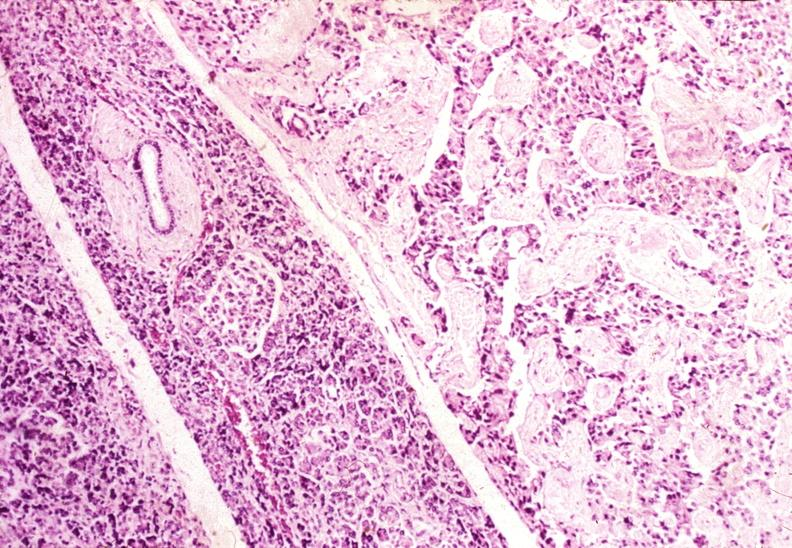s pancreas present?
Answer the question using a single word or phrase. Yes 